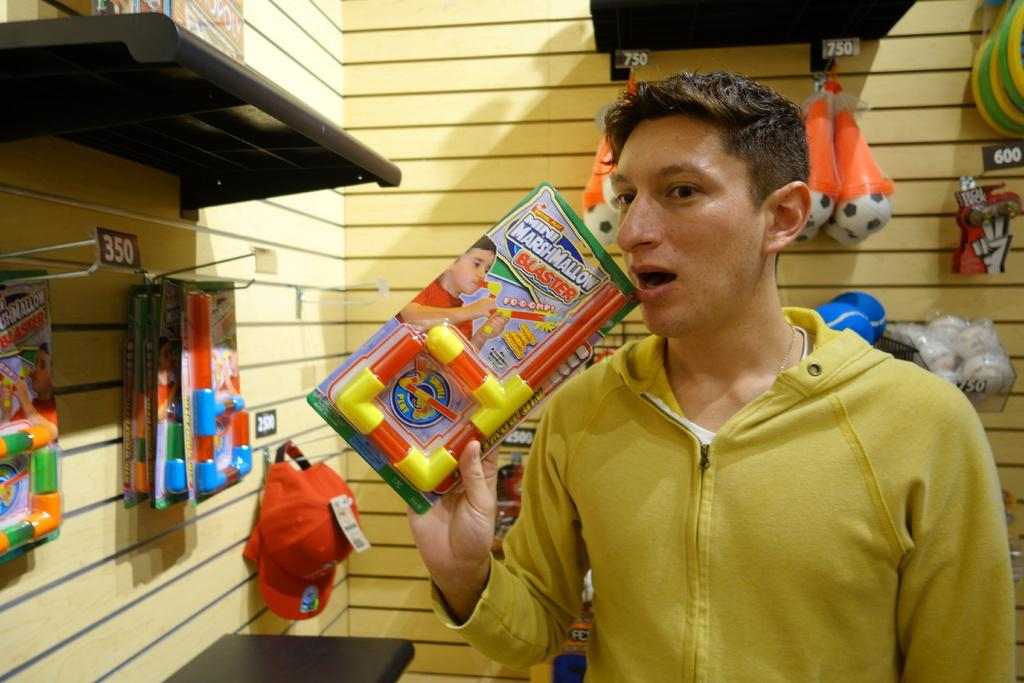What is the man in the image doing? The man is standing in the image and holding a toy in his hand. Can you describe the toy that the man is holding? Unfortunately, the specific toy cannot be identified from the provided facts. What can be seen in the background of the image? There is a wall in the background of the image. What else is associated with the wall in the background? There are toys associated with the wall in the background. What type of news can be heard coming from the bag in the image? There is no bag present in the image, and therefore no news can be heard coming from it. 